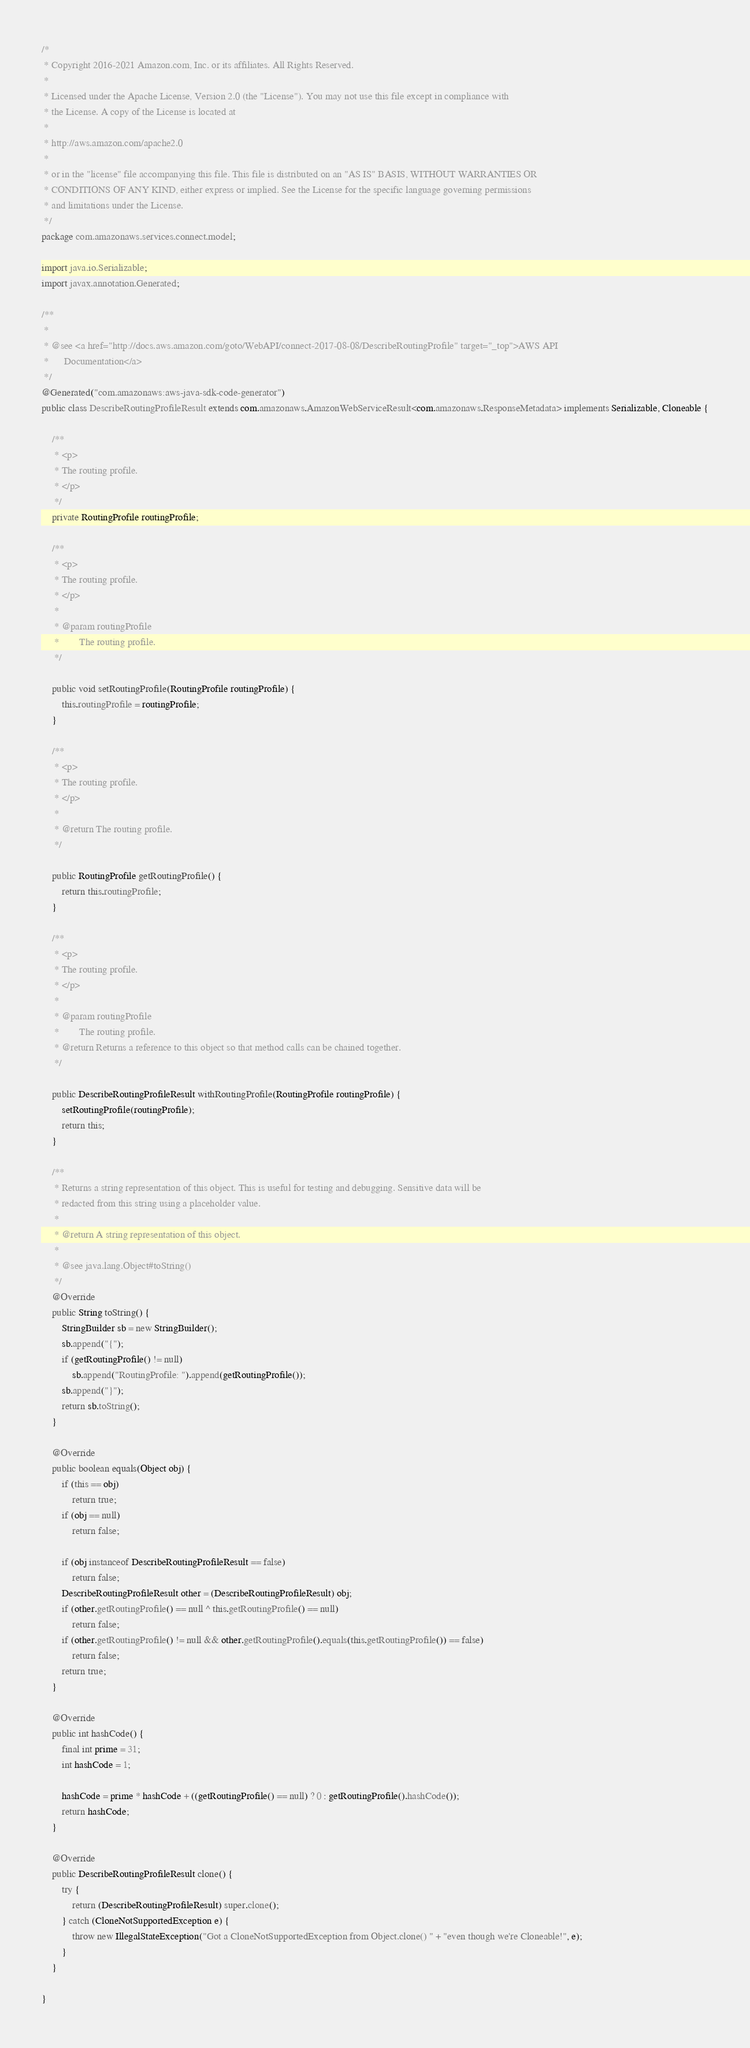<code> <loc_0><loc_0><loc_500><loc_500><_Java_>/*
 * Copyright 2016-2021 Amazon.com, Inc. or its affiliates. All Rights Reserved.
 * 
 * Licensed under the Apache License, Version 2.0 (the "License"). You may not use this file except in compliance with
 * the License. A copy of the License is located at
 * 
 * http://aws.amazon.com/apache2.0
 * 
 * or in the "license" file accompanying this file. This file is distributed on an "AS IS" BASIS, WITHOUT WARRANTIES OR
 * CONDITIONS OF ANY KIND, either express or implied. See the License for the specific language governing permissions
 * and limitations under the License.
 */
package com.amazonaws.services.connect.model;

import java.io.Serializable;
import javax.annotation.Generated;

/**
 * 
 * @see <a href="http://docs.aws.amazon.com/goto/WebAPI/connect-2017-08-08/DescribeRoutingProfile" target="_top">AWS API
 *      Documentation</a>
 */
@Generated("com.amazonaws:aws-java-sdk-code-generator")
public class DescribeRoutingProfileResult extends com.amazonaws.AmazonWebServiceResult<com.amazonaws.ResponseMetadata> implements Serializable, Cloneable {

    /**
     * <p>
     * The routing profile.
     * </p>
     */
    private RoutingProfile routingProfile;

    /**
     * <p>
     * The routing profile.
     * </p>
     * 
     * @param routingProfile
     *        The routing profile.
     */

    public void setRoutingProfile(RoutingProfile routingProfile) {
        this.routingProfile = routingProfile;
    }

    /**
     * <p>
     * The routing profile.
     * </p>
     * 
     * @return The routing profile.
     */

    public RoutingProfile getRoutingProfile() {
        return this.routingProfile;
    }

    /**
     * <p>
     * The routing profile.
     * </p>
     * 
     * @param routingProfile
     *        The routing profile.
     * @return Returns a reference to this object so that method calls can be chained together.
     */

    public DescribeRoutingProfileResult withRoutingProfile(RoutingProfile routingProfile) {
        setRoutingProfile(routingProfile);
        return this;
    }

    /**
     * Returns a string representation of this object. This is useful for testing and debugging. Sensitive data will be
     * redacted from this string using a placeholder value.
     *
     * @return A string representation of this object.
     *
     * @see java.lang.Object#toString()
     */
    @Override
    public String toString() {
        StringBuilder sb = new StringBuilder();
        sb.append("{");
        if (getRoutingProfile() != null)
            sb.append("RoutingProfile: ").append(getRoutingProfile());
        sb.append("}");
        return sb.toString();
    }

    @Override
    public boolean equals(Object obj) {
        if (this == obj)
            return true;
        if (obj == null)
            return false;

        if (obj instanceof DescribeRoutingProfileResult == false)
            return false;
        DescribeRoutingProfileResult other = (DescribeRoutingProfileResult) obj;
        if (other.getRoutingProfile() == null ^ this.getRoutingProfile() == null)
            return false;
        if (other.getRoutingProfile() != null && other.getRoutingProfile().equals(this.getRoutingProfile()) == false)
            return false;
        return true;
    }

    @Override
    public int hashCode() {
        final int prime = 31;
        int hashCode = 1;

        hashCode = prime * hashCode + ((getRoutingProfile() == null) ? 0 : getRoutingProfile().hashCode());
        return hashCode;
    }

    @Override
    public DescribeRoutingProfileResult clone() {
        try {
            return (DescribeRoutingProfileResult) super.clone();
        } catch (CloneNotSupportedException e) {
            throw new IllegalStateException("Got a CloneNotSupportedException from Object.clone() " + "even though we're Cloneable!", e);
        }
    }

}
</code> 